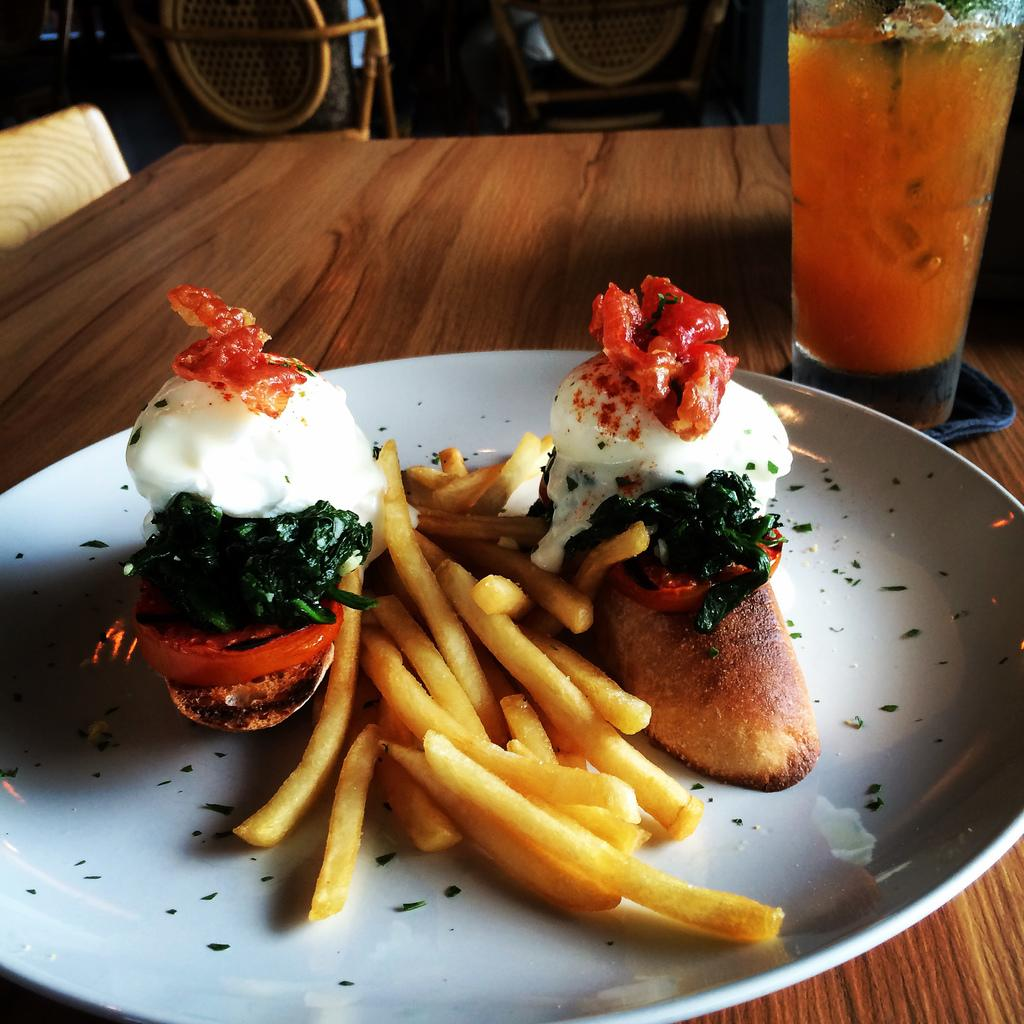What is on the plate in the image? There is food in a plate in the image. What is on the table besides the plate? There is a glass on the table in the image. What is inside the glass? There is a drink in the glass. What can be seen in the background of the image? There are chairs visible in the background of the image. Is there a mitten on the table in the image? No, there is no mitten present in the image. What type of connection can be seen between the food and the drink in the image? There is no direct connection between the food and the drink in the image; they are simply separate items on the table. 